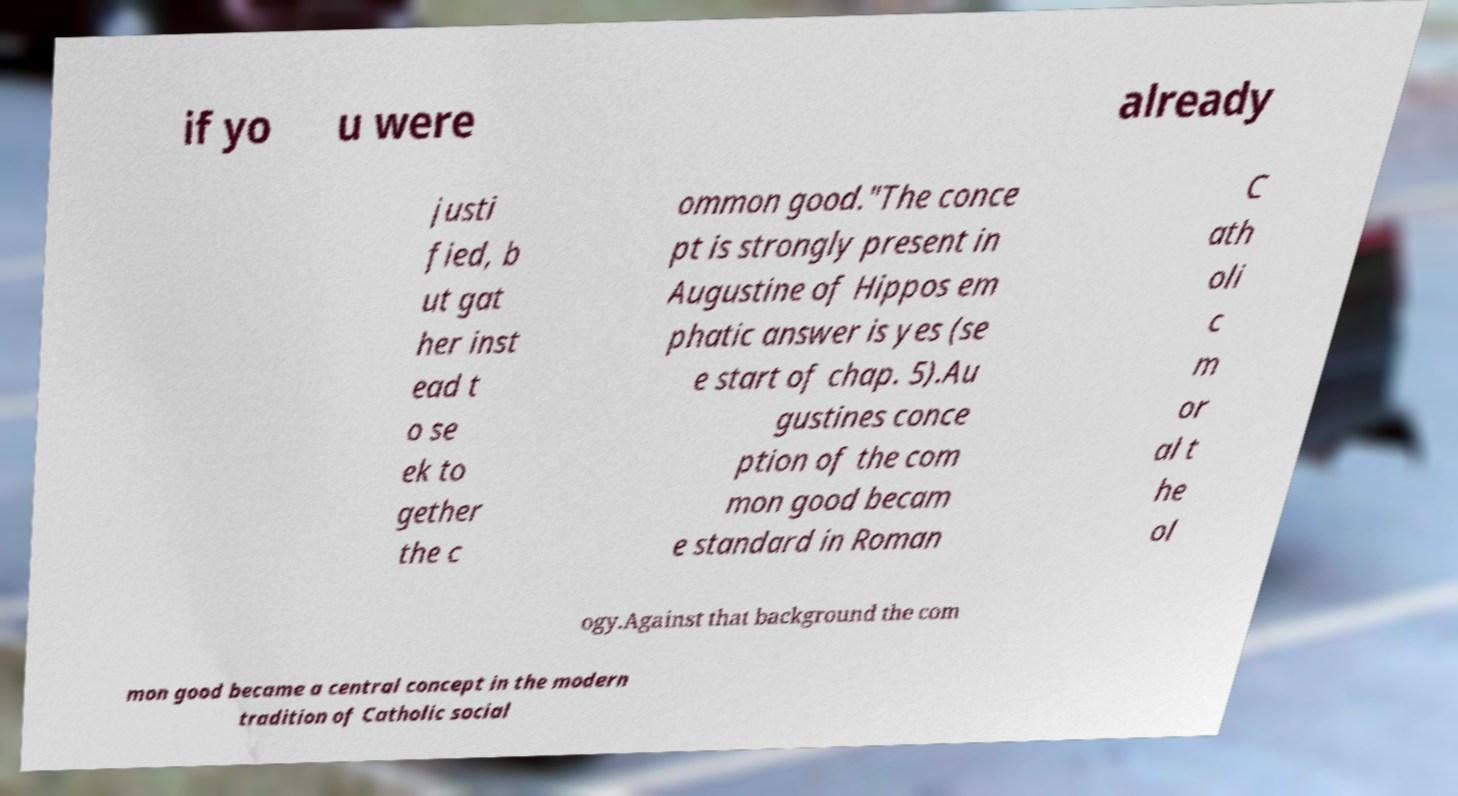Please identify and transcribe the text found in this image. if yo u were already justi fied, b ut gat her inst ead t o se ek to gether the c ommon good."The conce pt is strongly present in Augustine of Hippos em phatic answer is yes (se e start of chap. 5).Au gustines conce ption of the com mon good becam e standard in Roman C ath oli c m or al t he ol ogy.Against that background the com mon good became a central concept in the modern tradition of Catholic social 